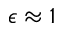<formula> <loc_0><loc_0><loc_500><loc_500>\epsilon \approx 1</formula> 